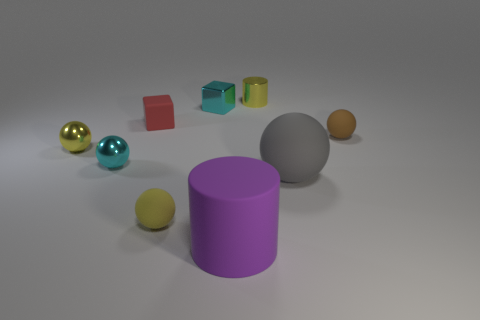What is the size of the cylinder that is the same material as the large gray ball?
Your answer should be compact. Large. Are there fewer brown rubber things than cyan shiny things?
Make the answer very short. Yes. There is a brown thing that is the same size as the red matte thing; what material is it?
Keep it short and to the point. Rubber. Are there more cyan blocks than small blue metallic spheres?
Provide a succinct answer. Yes. What number of other things are the same color as the matte cylinder?
Provide a succinct answer. 0. How many cyan things are in front of the yellow shiny sphere and on the right side of the tiny yellow rubber ball?
Your response must be concise. 0. Are there more big gray matte objects that are in front of the large cylinder than small brown objects that are left of the yellow matte sphere?
Give a very brief answer. No. What is the large thing that is behind the purple object made of?
Your answer should be very brief. Rubber. Does the large purple object have the same shape as the yellow metallic object that is behind the cyan cube?
Offer a terse response. Yes. There is a tiny matte ball to the right of the big matte thing that is behind the large purple cylinder; what number of rubber things are behind it?
Ensure brevity in your answer.  1. 